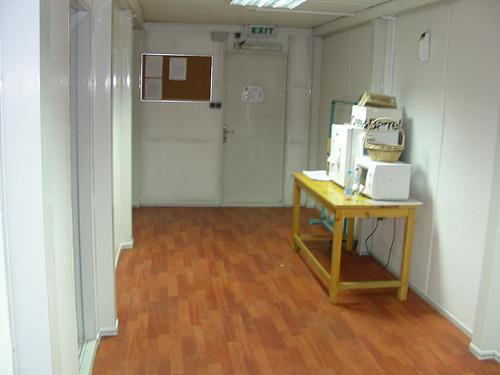Question: what is the floor color?
Choices:
A. Black.
B. White.
C. Tan.
D. Brown.
Answer with the letter. Answer: D Question: what is the color of the walls?
Choices:
A. White.
B. Blue.
C. Green.
D. Yellow.
Answer with the letter. Answer: A Question: what is the color of the table?
Choices:
A. Blue.
B. Yellow.
C. Green.
D. Purple.
Answer with the letter. Answer: B Question: what is in the wall?
Choices:
A. A picture.
B. A light.
C. A shelf.
D. Notice board.
Answer with the letter. Answer: D 